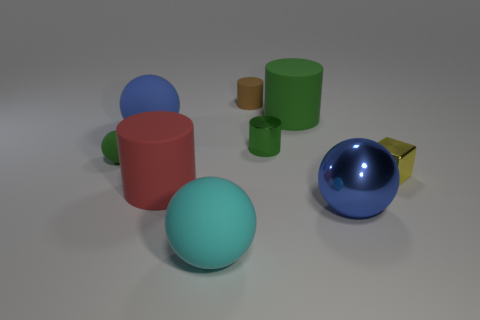What size is the matte cylinder that is the same color as the tiny rubber ball?
Your answer should be compact. Large. There is a tiny cylinder that is in front of the large green cylinder; what number of tiny yellow metallic things are to the left of it?
Provide a short and direct response. 0. How many other things are there of the same material as the small brown thing?
Provide a succinct answer. 5. Are the blue object that is behind the metal cube and the large cylinder left of the small brown rubber cylinder made of the same material?
Offer a very short reply. Yes. Are there any other things that are the same shape as the yellow object?
Give a very brief answer. No. Do the red cylinder and the big ball behind the yellow block have the same material?
Make the answer very short. Yes. There is a big matte object that is in front of the big cylinder that is in front of the metal object behind the yellow shiny thing; what is its color?
Your answer should be very brief. Cyan. There is a rubber thing that is the same size as the brown matte cylinder; what shape is it?
Make the answer very short. Sphere. Is there any other thing that is the same size as the shiny block?
Ensure brevity in your answer.  Yes. Does the blue thing that is on the left side of the tiny green metal cylinder have the same size as the blue object in front of the yellow metal thing?
Offer a terse response. Yes. 